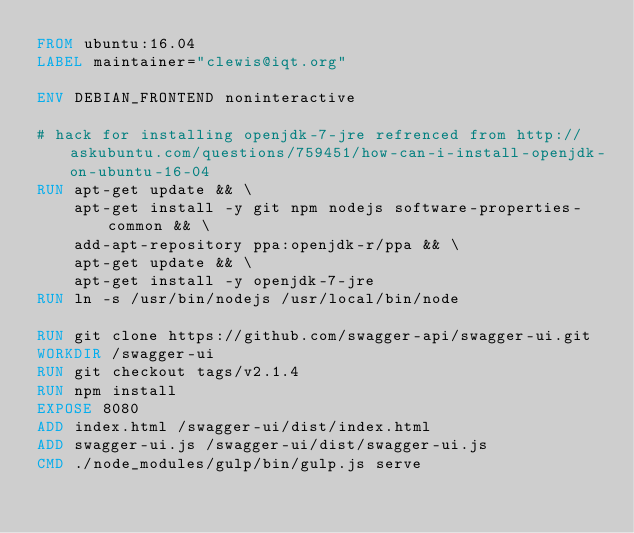<code> <loc_0><loc_0><loc_500><loc_500><_Dockerfile_>FROM ubuntu:16.04
LABEL maintainer="clewis@iqt.org"

ENV DEBIAN_FRONTEND noninteractive

# hack for installing openjdk-7-jre refrenced from http://askubuntu.com/questions/759451/how-can-i-install-openjdk-on-ubuntu-16-04
RUN apt-get update && \
    apt-get install -y git npm nodejs software-properties-common && \
    add-apt-repository ppa:openjdk-r/ppa && \
    apt-get update && \
    apt-get install -y openjdk-7-jre
RUN ln -s /usr/bin/nodejs /usr/local/bin/node

RUN git clone https://github.com/swagger-api/swagger-ui.git
WORKDIR /swagger-ui
RUN git checkout tags/v2.1.4
RUN npm install
EXPOSE 8080
ADD index.html /swagger-ui/dist/index.html
ADD swagger-ui.js /swagger-ui/dist/swagger-ui.js
CMD ./node_modules/gulp/bin/gulp.js serve
</code> 